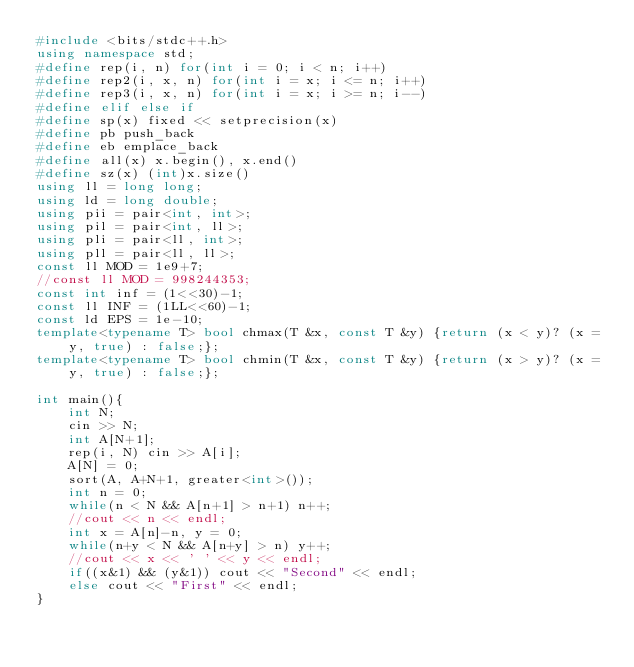<code> <loc_0><loc_0><loc_500><loc_500><_C++_>#include <bits/stdc++.h>
using namespace std;
#define rep(i, n) for(int i = 0; i < n; i++)
#define rep2(i, x, n) for(int i = x; i <= n; i++)
#define rep3(i, x, n) for(int i = x; i >= n; i--)
#define elif else if
#define sp(x) fixed << setprecision(x)
#define pb push_back
#define eb emplace_back
#define all(x) x.begin(), x.end()
#define sz(x) (int)x.size()
using ll = long long;
using ld = long double;
using pii = pair<int, int>;
using pil = pair<int, ll>;
using pli = pair<ll, int>;
using pll = pair<ll, ll>;
const ll MOD = 1e9+7;
//const ll MOD = 998244353;
const int inf = (1<<30)-1;
const ll INF = (1LL<<60)-1;
const ld EPS = 1e-10;
template<typename T> bool chmax(T &x, const T &y) {return (x < y)? (x = y, true) : false;};
template<typename T> bool chmin(T &x, const T &y) {return (x > y)? (x = y, true) : false;};

int main(){
    int N;
    cin >> N;
    int A[N+1];
    rep(i, N) cin >> A[i];
    A[N] = 0;
    sort(A, A+N+1, greater<int>());
    int n = 0;
    while(n < N && A[n+1] > n+1) n++;
    //cout << n << endl;
    int x = A[n]-n, y = 0;
    while(n+y < N && A[n+y] > n) y++;
    //cout << x << ' ' << y << endl;
    if((x&1) && (y&1)) cout << "Second" << endl;
    else cout << "First" << endl;
}</code> 